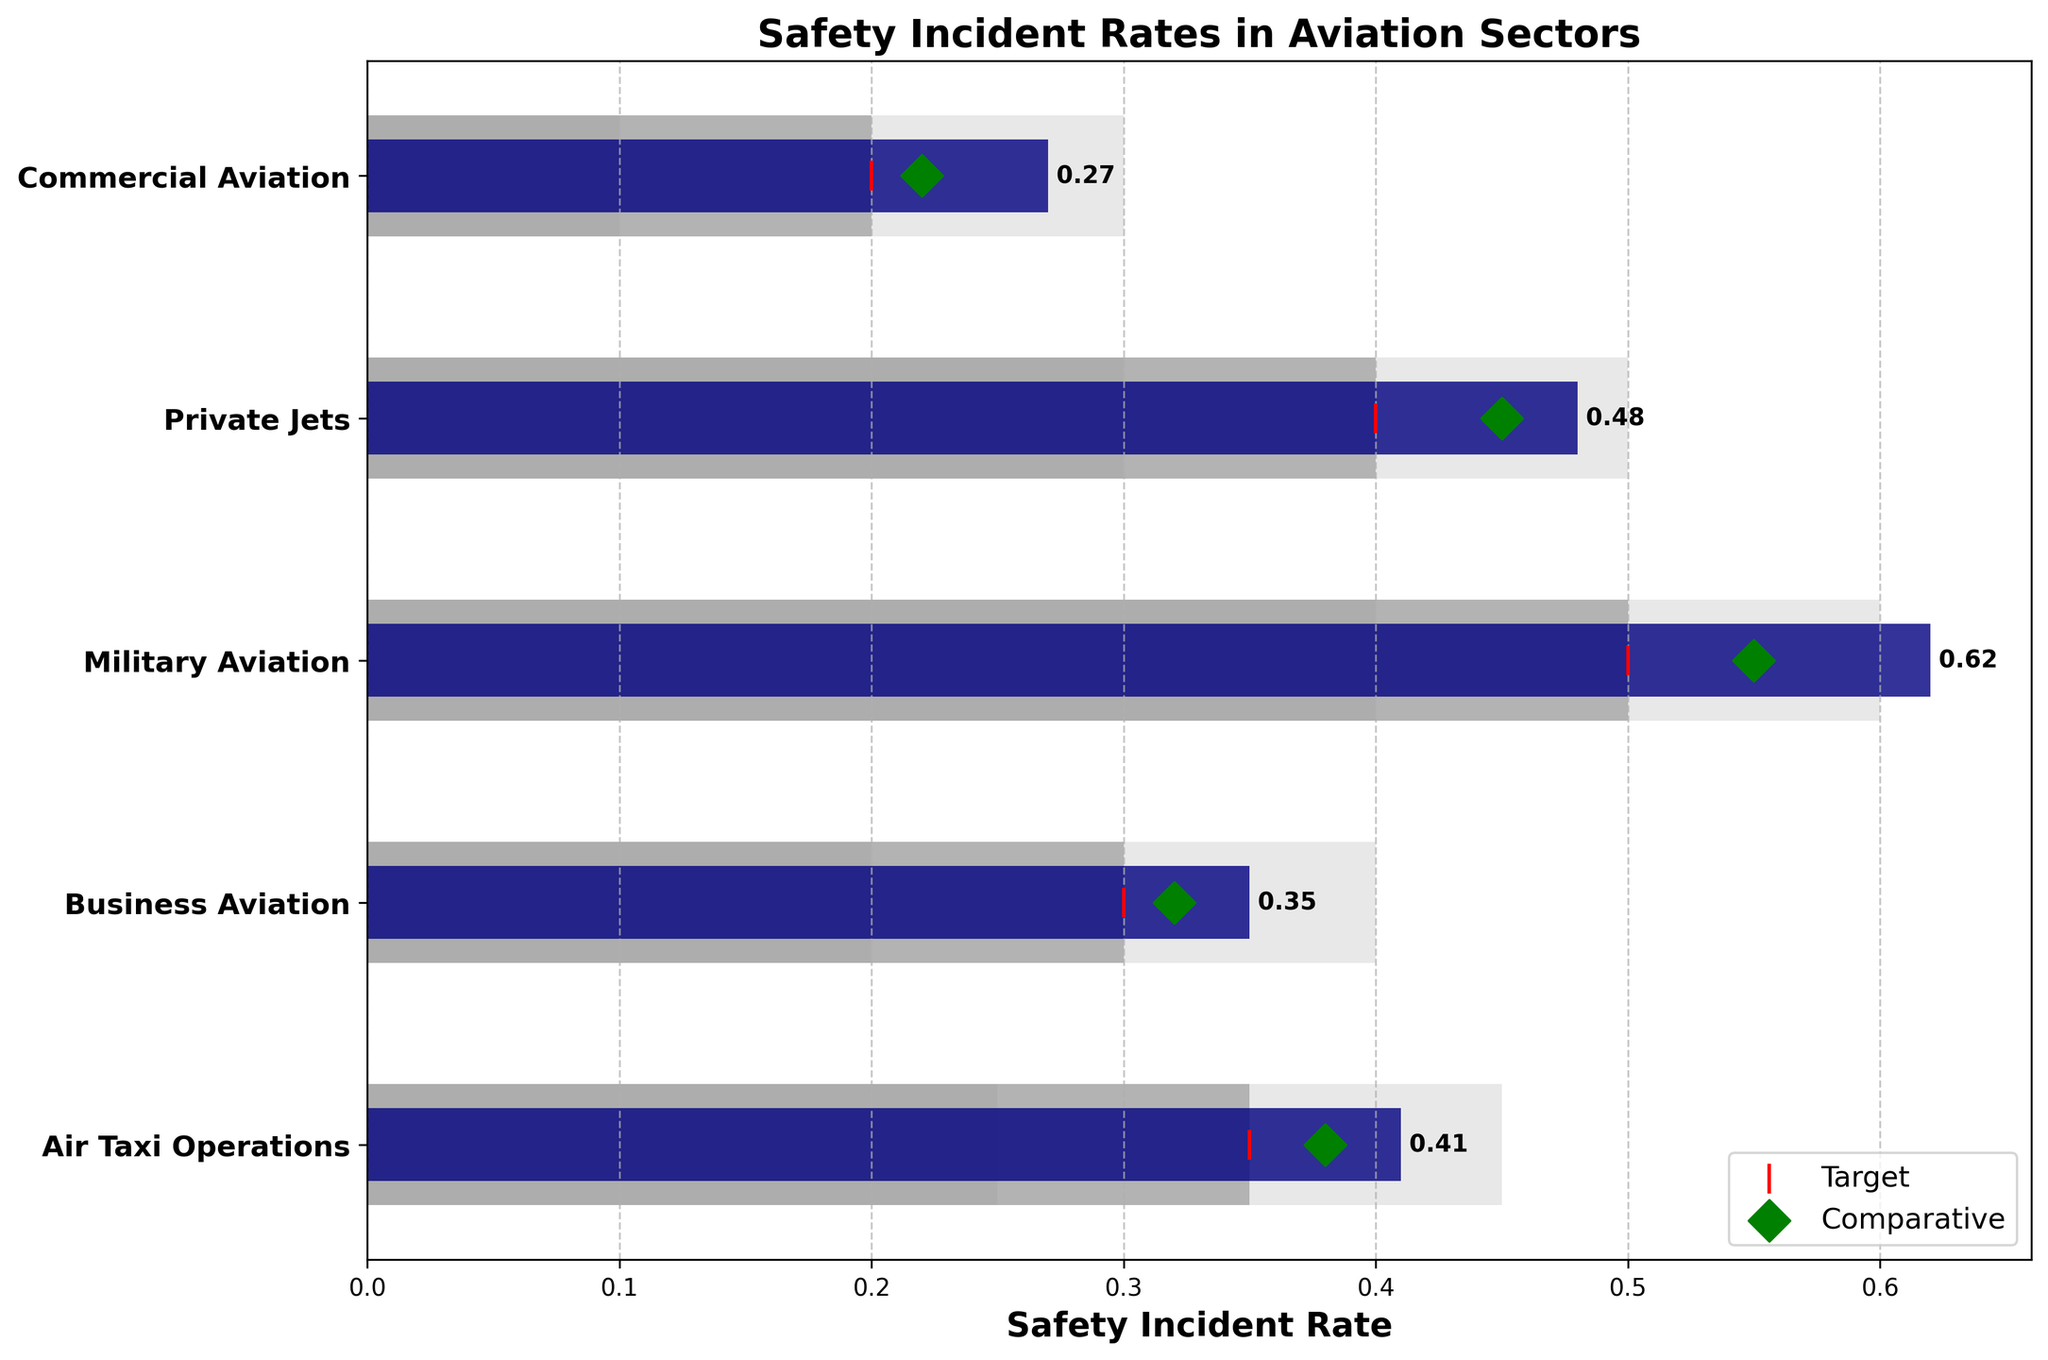What's the title of the figure? The title of the figure is typically located at the top and is often in bold. It summarizes what the graph is about.
Answer: Safety Incident Rates in Aviation Sectors What does the red marker represent? In the legend, the red marker is described. This marker, a vertical red line, is labeled as 'Target'.
Answer: Target Which sector has the highest safety incident rate? To answer, look at the actual values represented by the navy bars and identify the longest bar.
Answer: Military Aviation How does the actual safety incident rate of Private Jets compare to its target? Compare the length of the navy bar (actual value) for Private Jets to the red marker (target value). The navy bar extends to 0.48 while the target marker is at 0.4.
Answer: Actual rate is higher than the target What is the difference in the actual safety incident rates between Commercial Aviation and Business Aviation? The navy bar for Commercial Aviation is at 0.27, and for Business Aviation, it's at 0.35. The difference is calculated as 0.35 - 0.27.
Answer: 0.08 Which sector has the closest actual rate to its comparative marker value? Examine the navy bars (actual values) and green diamond markers (comparative values) for each sector. Find the smallest difference. For Air Taxi Operations, actual is 0.41 and comparative is 0.38, which is a difference of 0.03, the smallest difference observed.
Answer: Air Taxi Operations Which sector's actual safety incident rate is within its acceptable range (Range2)? For each sector, check if the actual value (navy bar) falls within the bounds of the second range (grey bar). For Air Taxi Operations, actual (0.41) is within 0.35-0.45.
Answer: Air Taxi Operations What is the average target value across all sectors? Calculate the average of all target values by summing them up (0.2 + 0.4 + 0.5 + 0.3 + 0.35) and dividing by the number of sectors (5).
Answer: 0.35 What is the difference between the highest comparative marker and the lowest actual rate? Identify the highest comparative value, which is for Military Aviation (0.55), and the lowest actual rate, which is for Commercial Aviation (0.27). The difference is 0.55 - 0.27.
Answer: 0.28 